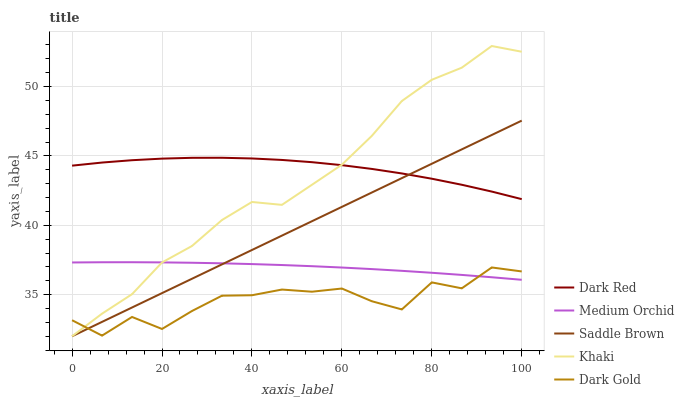Does Medium Orchid have the minimum area under the curve?
Answer yes or no. No. Does Medium Orchid have the maximum area under the curve?
Answer yes or no. No. Is Medium Orchid the smoothest?
Answer yes or no. No. Is Medium Orchid the roughest?
Answer yes or no. No. Does Medium Orchid have the lowest value?
Answer yes or no. No. Does Medium Orchid have the highest value?
Answer yes or no. No. Is Dark Gold less than Dark Red?
Answer yes or no. Yes. Is Dark Red greater than Medium Orchid?
Answer yes or no. Yes. Does Dark Gold intersect Dark Red?
Answer yes or no. No. 